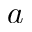<formula> <loc_0><loc_0><loc_500><loc_500>a</formula> 